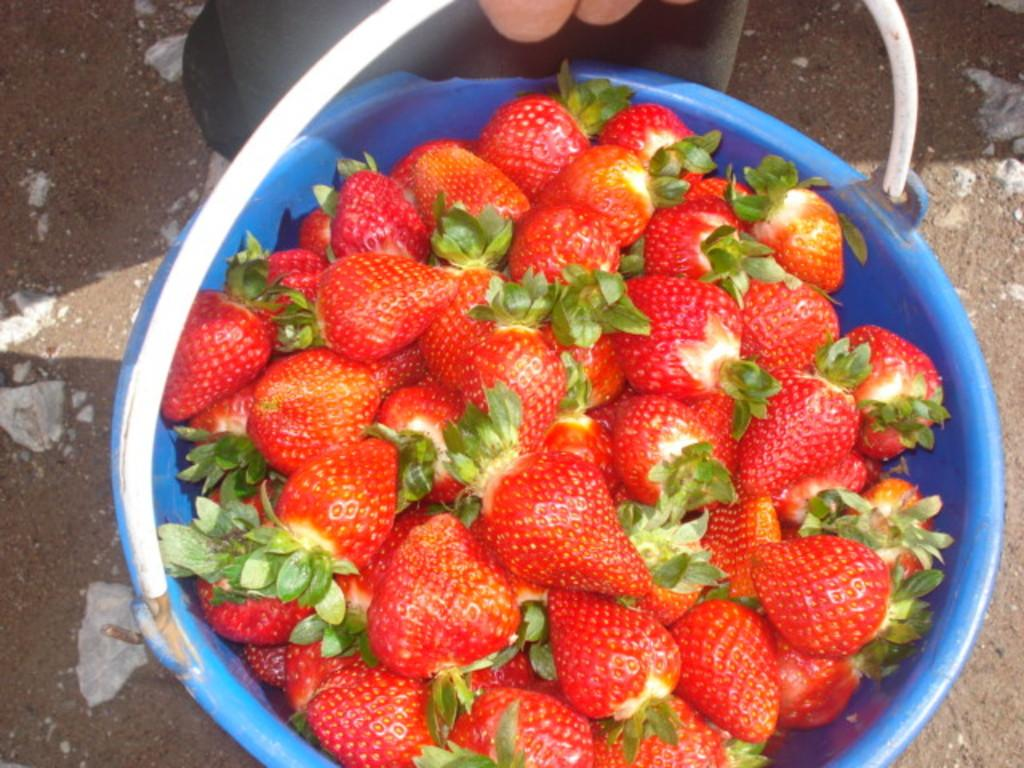What object is present in the image that can hold items? There is a bucket in the image. What is inside the bucket? The bucket contains strawberries. Can you describe the person in the image? There is a person in the image, but no specific details about their appearance or actions are provided. What can be seen at the bottom of the image? The ground is visible at the bottom of the image. What type of mind control device is being used by the person in the image? There is no mention of a mind control device or any mind control activity in the image. 